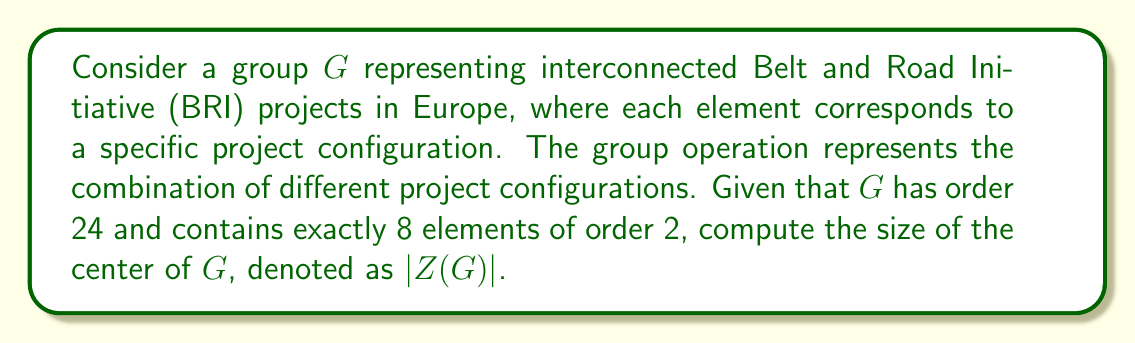Show me your answer to this math problem. To solve this problem, we'll use the following steps:

1) First, recall that in any group $G$, the class equation is given by:

   $$|G| = |Z(G)| + \sum_{[x] \neq \{e\}} |[x]|$$

   where $|G|$ is the order of the group, $|Z(G)|$ is the size of the center, and $|[x]|$ are the sizes of non-trivial conjugacy classes.

2) We know that $|G| = 24$. Let's consider the possible sizes of conjugacy classes:
   - The size of a conjugacy class must divide the order of the group.
   - The possible divisors of 24 are 1, 2, 3, 4, 6, 8, 12, and 24.

3) We're told that there are exactly 8 elements of order 2. In a group of order 24, elements of order 2 can only be in conjugacy classes of size 1, 2, or 4.

4) The only way to have exactly 8 elements of order 2 is to have:
   - One conjugacy class of size 1 (the identity element)
   - One conjugacy class of size 1 (an element in the center)
   - One conjugacy class of size 6

5) This accounts for 1 + 1 + 6 = 8 elements. The remaining 16 elements must be in conjugacy classes whose sizes add up to 16.

6) The only way to partition 16 using the remaining possible class sizes is 4 + 12.

7) Therefore, the class equation for this group is:

   $$24 = |Z(G)| + 1 + 6 + 4 + 12$$

8) Solving for $|Z(G)|$:

   $$|Z(G)| = 24 - (1 + 6 + 4 + 12) = 24 - 23 = 1$$

Therefore, the size of the center of $G$ is 1.
Answer: $|Z(G)| = 1$ 